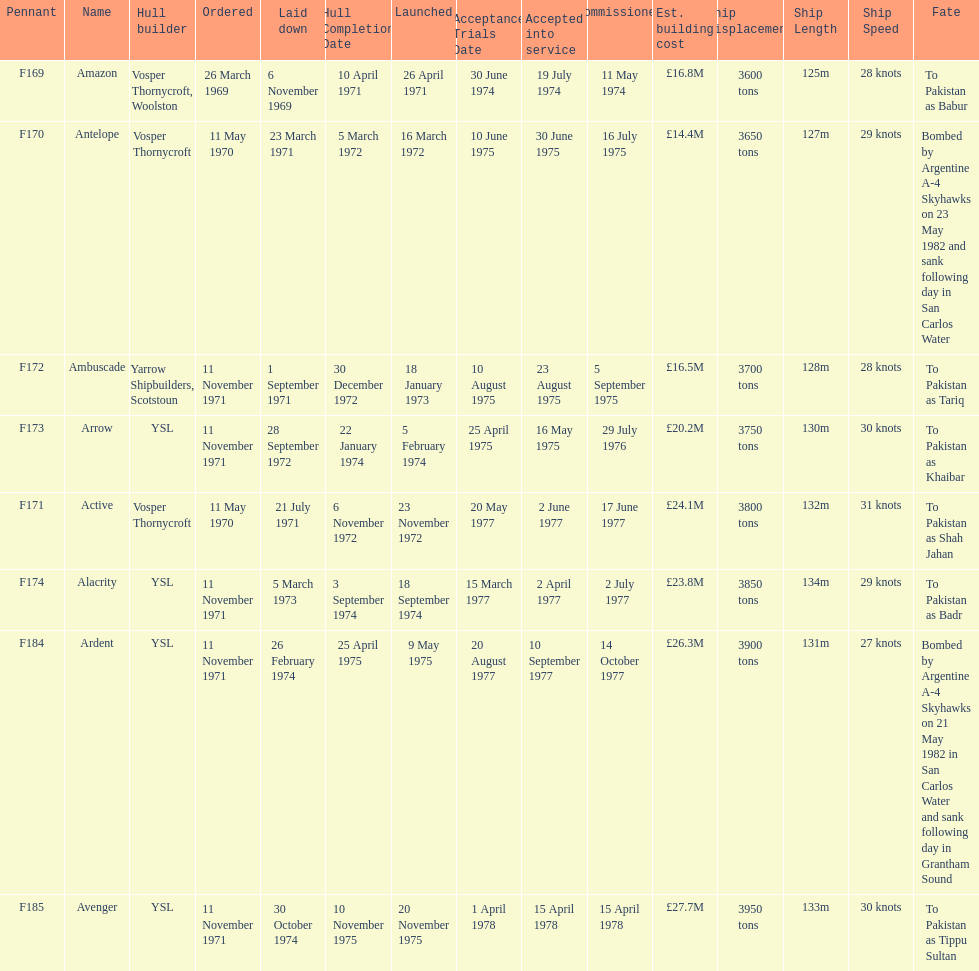Tell me the number of ships that went to pakistan. 6. Can you parse all the data within this table? {'header': ['Pennant', 'Name', 'Hull builder', 'Ordered', 'Laid down', 'Hull Completion Date', 'Launched', 'Acceptance Trials Date', 'Accepted into service', 'Commissioned', 'Est. building cost', 'Ship Displacement', 'Ship Length', 'Ship Speed', 'Fate'], 'rows': [['F169', 'Amazon', 'Vosper Thornycroft, Woolston', '26 March 1969', '6 November 1969', '10 April 1971', '26 April 1971', '30 June 1974', '19 July 1974', '11 May 1974', '£16.8M', '3600 tons', '125m', '28 knots', 'To Pakistan as Babur'], ['F170', 'Antelope', 'Vosper Thornycroft', '11 May 1970', '23 March 1971', '5 March 1972', '16 March 1972', '10 June 1975', '30 June 1975', '16 July 1975', '£14.4M', '3650 tons', '127m', '29 knots', 'Bombed by Argentine A-4 Skyhawks on 23 May 1982 and sank following day in San Carlos Water'], ['F172', 'Ambuscade', 'Yarrow Shipbuilders, Scotstoun', '11 November 1971', '1 September 1971', '30 December 1972', '18 January 1973', '10 August 1975', '23 August 1975', '5 September 1975', '£16.5M', '3700 tons', '128m', '28 knots', 'To Pakistan as Tariq'], ['F173', 'Arrow', 'YSL', '11 November 1971', '28 September 1972', '22 January 1974', '5 February 1974', '25 April 1975', '16 May 1975', '29 July 1976', '£20.2M', '3750 tons', '130m', '30 knots', 'To Pakistan as Khaibar'], ['F171', 'Active', 'Vosper Thornycroft', '11 May 1970', '21 July 1971', '6 November 1972', '23 November 1972', '20 May 1977', '2 June 1977', '17 June 1977', '£24.1M', '3800 tons', '132m', '31 knots', 'To Pakistan as Shah Jahan'], ['F174', 'Alacrity', 'YSL', '11 November 1971', '5 March 1973', '3 September 1974', '18 September 1974', '15 March 1977', '2 April 1977', '2 July 1977', '£23.8M', '3850 tons', '134m', '29 knots', 'To Pakistan as Badr'], ['F184', 'Ardent', 'YSL', '11 November 1971', '26 February 1974', '25 April 1975', '9 May 1975', '20 August 1977', '10 September 1977', '14 October 1977', '£26.3M', '3900 tons', '131m', '27 knots', 'Bombed by Argentine A-4 Skyhawks on 21 May 1982 in San Carlos Water and sank following day in Grantham Sound'], ['F185', 'Avenger', 'YSL', '11 November 1971', '30 October 1974', '10 November 1975', '20 November 1975', '1 April 1978', '15 April 1978', '15 April 1978', '£27.7M', '3950 tons', '133m', '30 knots', 'To Pakistan as Tippu Sultan']]} 